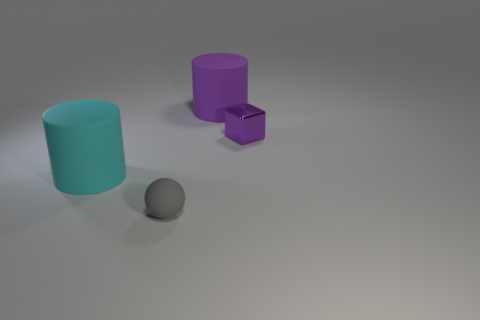The other big cylinder that is made of the same material as the large purple cylinder is what color?
Your response must be concise. Cyan. How many large cyan things are made of the same material as the large purple cylinder?
Provide a short and direct response. 1. What is the color of the large rubber thing in front of the purple matte cylinder that is behind the cyan cylinder that is behind the gray matte ball?
Offer a terse response. Cyan. Is the gray matte object the same size as the purple cylinder?
Ensure brevity in your answer.  No. Are there any other things that have the same shape as the tiny purple thing?
Give a very brief answer. No. What number of objects are big matte cylinders that are left of the ball or large matte things?
Your answer should be very brief. 2. Do the small purple metal object and the small gray matte thing have the same shape?
Give a very brief answer. No. How many other objects are there of the same size as the block?
Ensure brevity in your answer.  1. What is the color of the tiny metal thing?
Provide a short and direct response. Purple. How many large things are gray rubber spheres or cyan matte things?
Provide a succinct answer. 1. 